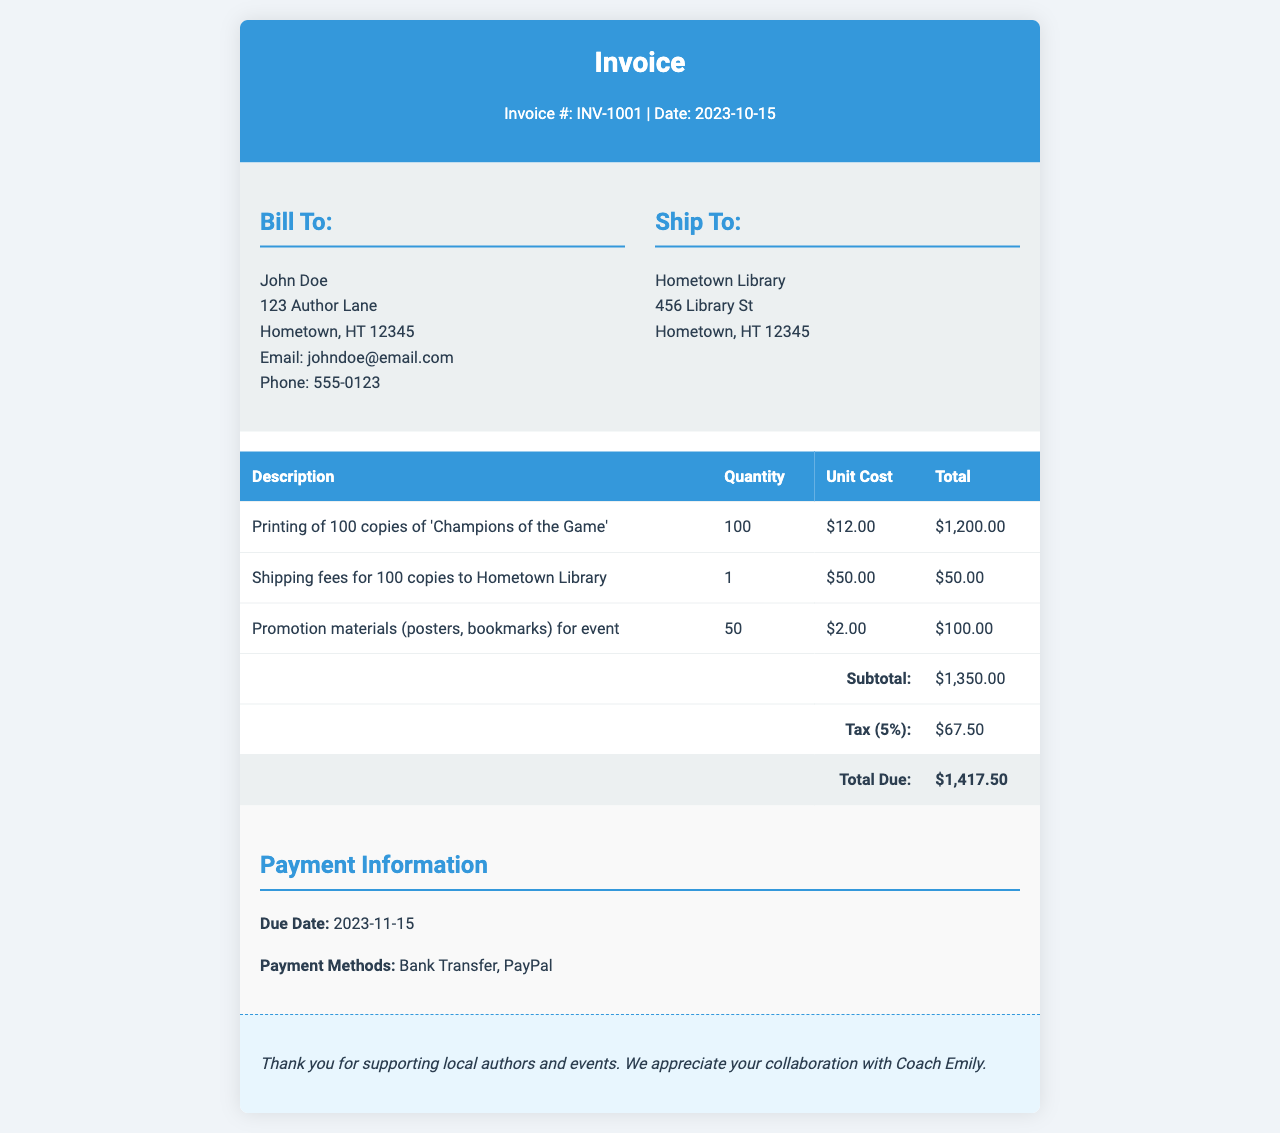What is the invoice number? The invoice number is listed at the top of the document under the title "Invoice."
Answer: INV-1001 What is the date of the invoice? The date is mentioned next to the invoice number at the top.
Answer: 2023-10-15 What is the total amount due? The total amount due is found in the total row of the table at the bottom.
Answer: $1,417.50 Who is the invoice billed to? The information is provided in the "Bill To" section and includes the name of the person.
Answer: John Doe What is the shipping fee? The shipping fee can be found in the table under the relevant description.
Answer: $50.00 How many copies of the book were printed? The quantity of book copies printed is specified in the first row of the table.
Answer: 100 What is the tax percentage applied? The tax percentage is mentioned in the table right before the total due amount.
Answer: 5% What is the due date for payment? The due date is located in the "Payment Information" section.
Answer: 2023-11-15 What payment methods are accepted? The accepted payment methods are listed in the "Payment Information" section.
Answer: Bank Transfer, PayPal 